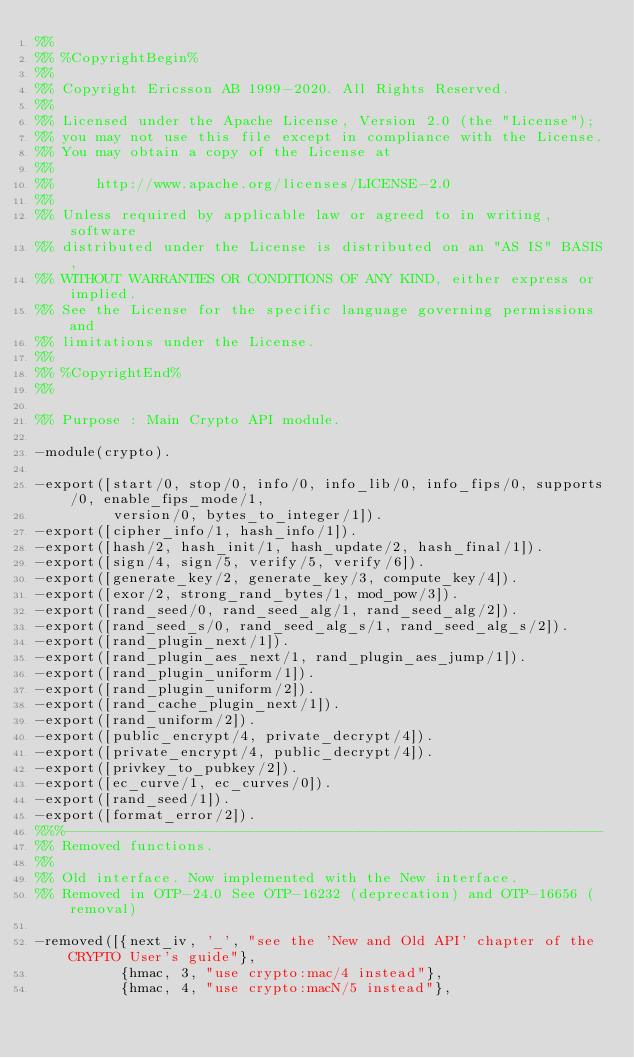<code> <loc_0><loc_0><loc_500><loc_500><_Erlang_>%%
%% %CopyrightBegin%
%%
%% Copyright Ericsson AB 1999-2020. All Rights Reserved.
%%
%% Licensed under the Apache License, Version 2.0 (the "License");
%% you may not use this file except in compliance with the License.
%% You may obtain a copy of the License at
%%
%%     http://www.apache.org/licenses/LICENSE-2.0
%%
%% Unless required by applicable law or agreed to in writing, software
%% distributed under the License is distributed on an "AS IS" BASIS,
%% WITHOUT WARRANTIES OR CONDITIONS OF ANY KIND, either express or implied.
%% See the License for the specific language governing permissions and
%% limitations under the License.
%%
%% %CopyrightEnd%
%%

%% Purpose : Main Crypto API module.

-module(crypto).

-export([start/0, stop/0, info/0, info_lib/0, info_fips/0, supports/0, enable_fips_mode/1,
         version/0, bytes_to_integer/1]).
-export([cipher_info/1, hash_info/1]).
-export([hash/2, hash_init/1, hash_update/2, hash_final/1]).
-export([sign/4, sign/5, verify/5, verify/6]).
-export([generate_key/2, generate_key/3, compute_key/4]).
-export([exor/2, strong_rand_bytes/1, mod_pow/3]).
-export([rand_seed/0, rand_seed_alg/1, rand_seed_alg/2]).
-export([rand_seed_s/0, rand_seed_alg_s/1, rand_seed_alg_s/2]).
-export([rand_plugin_next/1]).
-export([rand_plugin_aes_next/1, rand_plugin_aes_jump/1]).
-export([rand_plugin_uniform/1]).
-export([rand_plugin_uniform/2]).
-export([rand_cache_plugin_next/1]).
-export([rand_uniform/2]).
-export([public_encrypt/4, private_decrypt/4]).
-export([private_encrypt/4, public_decrypt/4]).
-export([privkey_to_pubkey/2]).
-export([ec_curve/1, ec_curves/0]).
-export([rand_seed/1]).
-export([format_error/2]).
%%%----------------------------------------------------------------
%% Removed functions.
%%
%% Old interface. Now implemented with the New interface.
%% Removed in OTP-24.0 See OTP-16232 (deprecation) and OTP-16656 (removal)

-removed([{next_iv, '_', "see the 'New and Old API' chapter of the CRYPTO User's guide"},
          {hmac, 3, "use crypto:mac/4 instead"},
          {hmac, 4, "use crypto:macN/5 instead"},</code> 